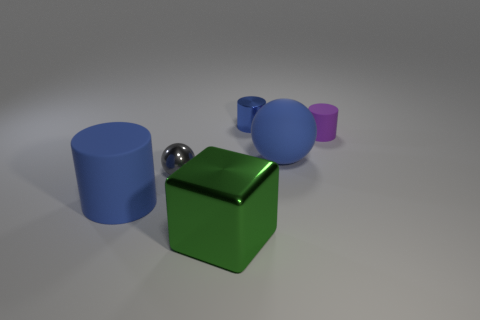There is a block that is the same size as the blue matte cylinder; what is it made of?
Your answer should be compact. Metal. How many blue rubber things are the same shape as the purple object?
Ensure brevity in your answer.  1. How many objects are small things that are left of the purple matte thing or cylinders on the left side of the purple rubber object?
Offer a terse response. 3. What material is the blue thing that is behind the large blue object on the right side of the small metallic object that is behind the small gray sphere?
Ensure brevity in your answer.  Metal. There is a big rubber thing that is to the right of the big blue cylinder; is its color the same as the large rubber cylinder?
Ensure brevity in your answer.  Yes. There is a large object that is right of the blue rubber cylinder and to the left of the tiny blue object; what is it made of?
Your answer should be very brief. Metal. Is there a red object of the same size as the block?
Provide a short and direct response. No. How many small yellow rubber cylinders are there?
Ensure brevity in your answer.  0. There is a big cylinder; what number of big blue things are to the right of it?
Keep it short and to the point. 1. Is the material of the big green block the same as the big cylinder?
Provide a succinct answer. No. 